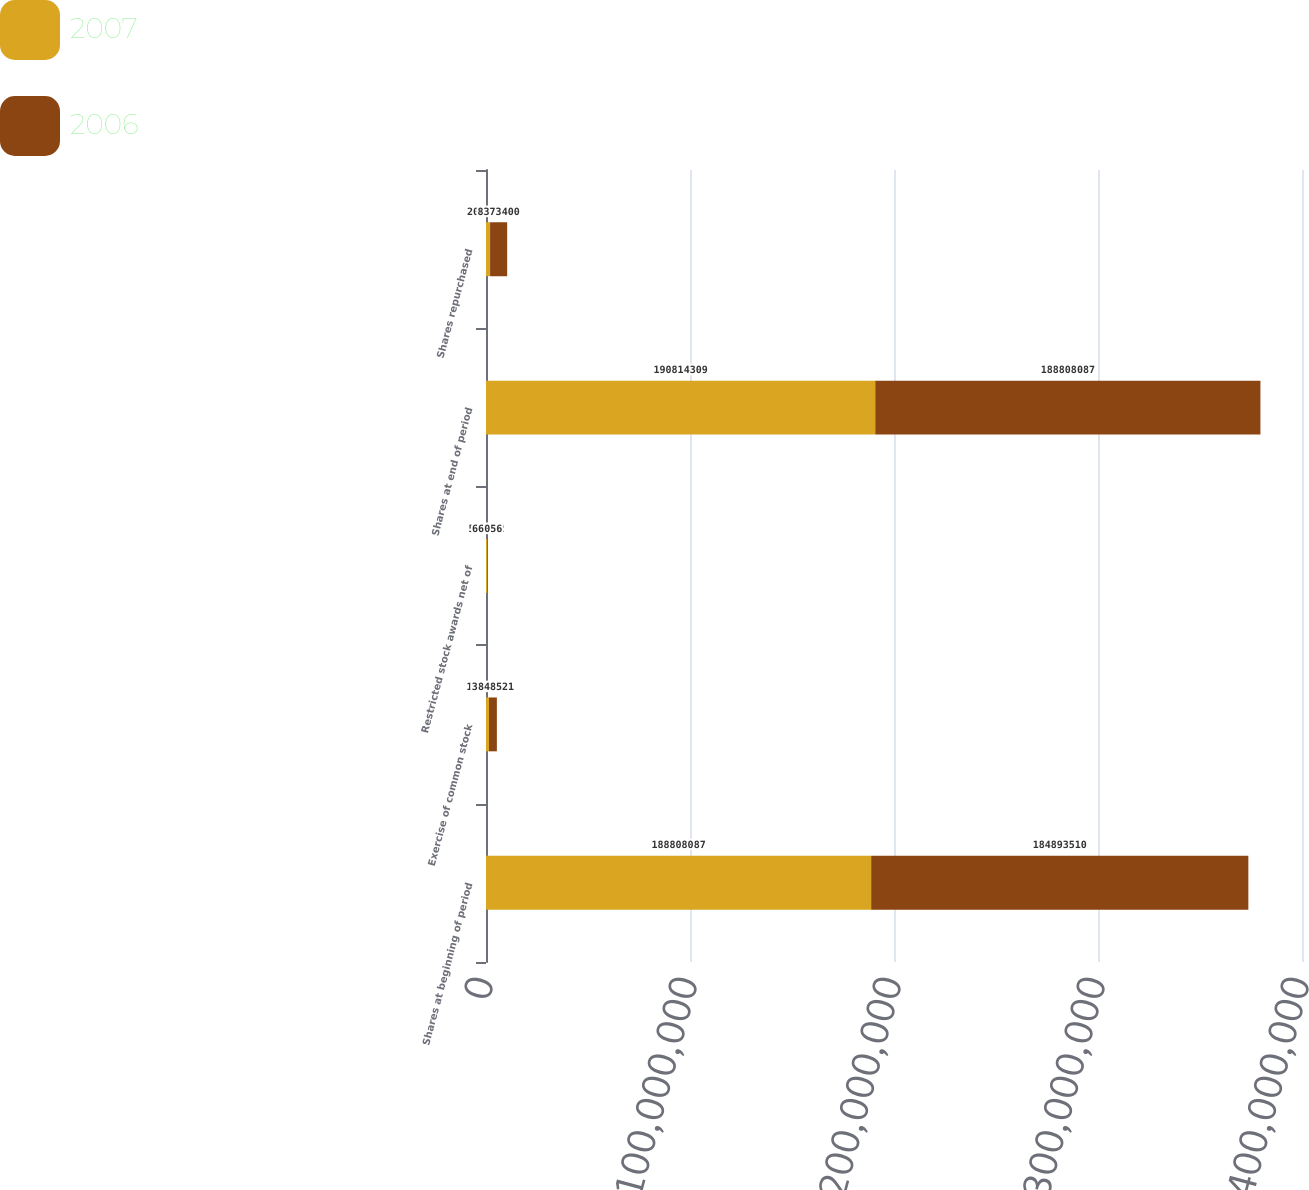<chart> <loc_0><loc_0><loc_500><loc_500><stacked_bar_chart><ecel><fcel>Shares at beginning of period<fcel>Exercise of common stock<fcel>Restricted stock awards net of<fcel>Shares at end of period<fcel>Shares repurchased<nl><fcel>2007<fcel>1.88808e+08<fcel>1.47904e+06<fcel>527182<fcel>1.90814e+08<fcel>2.00648e+06<nl><fcel>2006<fcel>1.84894e+08<fcel>3.84852e+06<fcel>66056<fcel>1.88808e+08<fcel>8.3734e+06<nl></chart> 